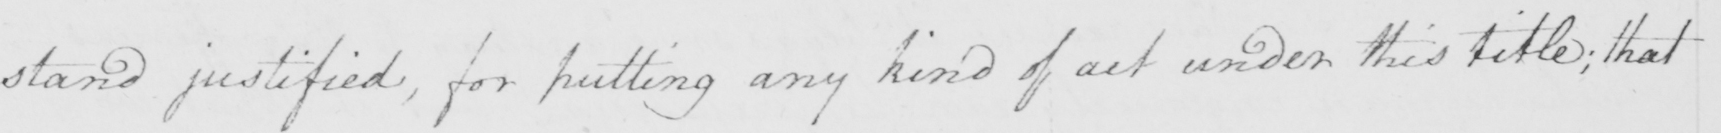What is written in this line of handwriting? stand justified , for putting any kind of act under this title ; that 